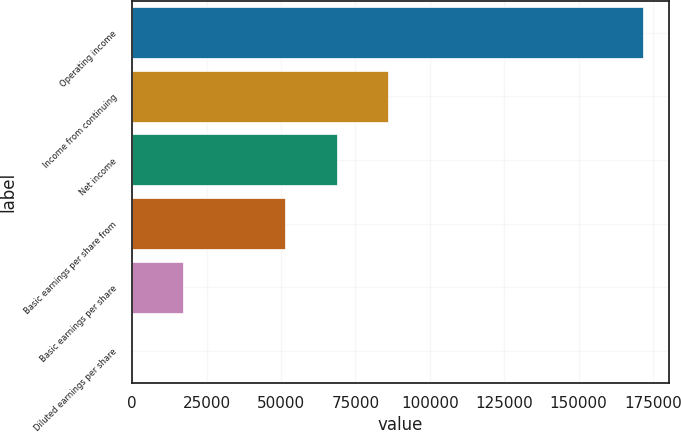<chart> <loc_0><loc_0><loc_500><loc_500><bar_chart><fcel>Operating income<fcel>Income from continuing<fcel>Net income<fcel>Basic earnings per share from<fcel>Basic earnings per share<fcel>Diluted earnings per share<nl><fcel>171752<fcel>85876.3<fcel>68701.2<fcel>51526<fcel>17175.7<fcel>0.6<nl></chart> 